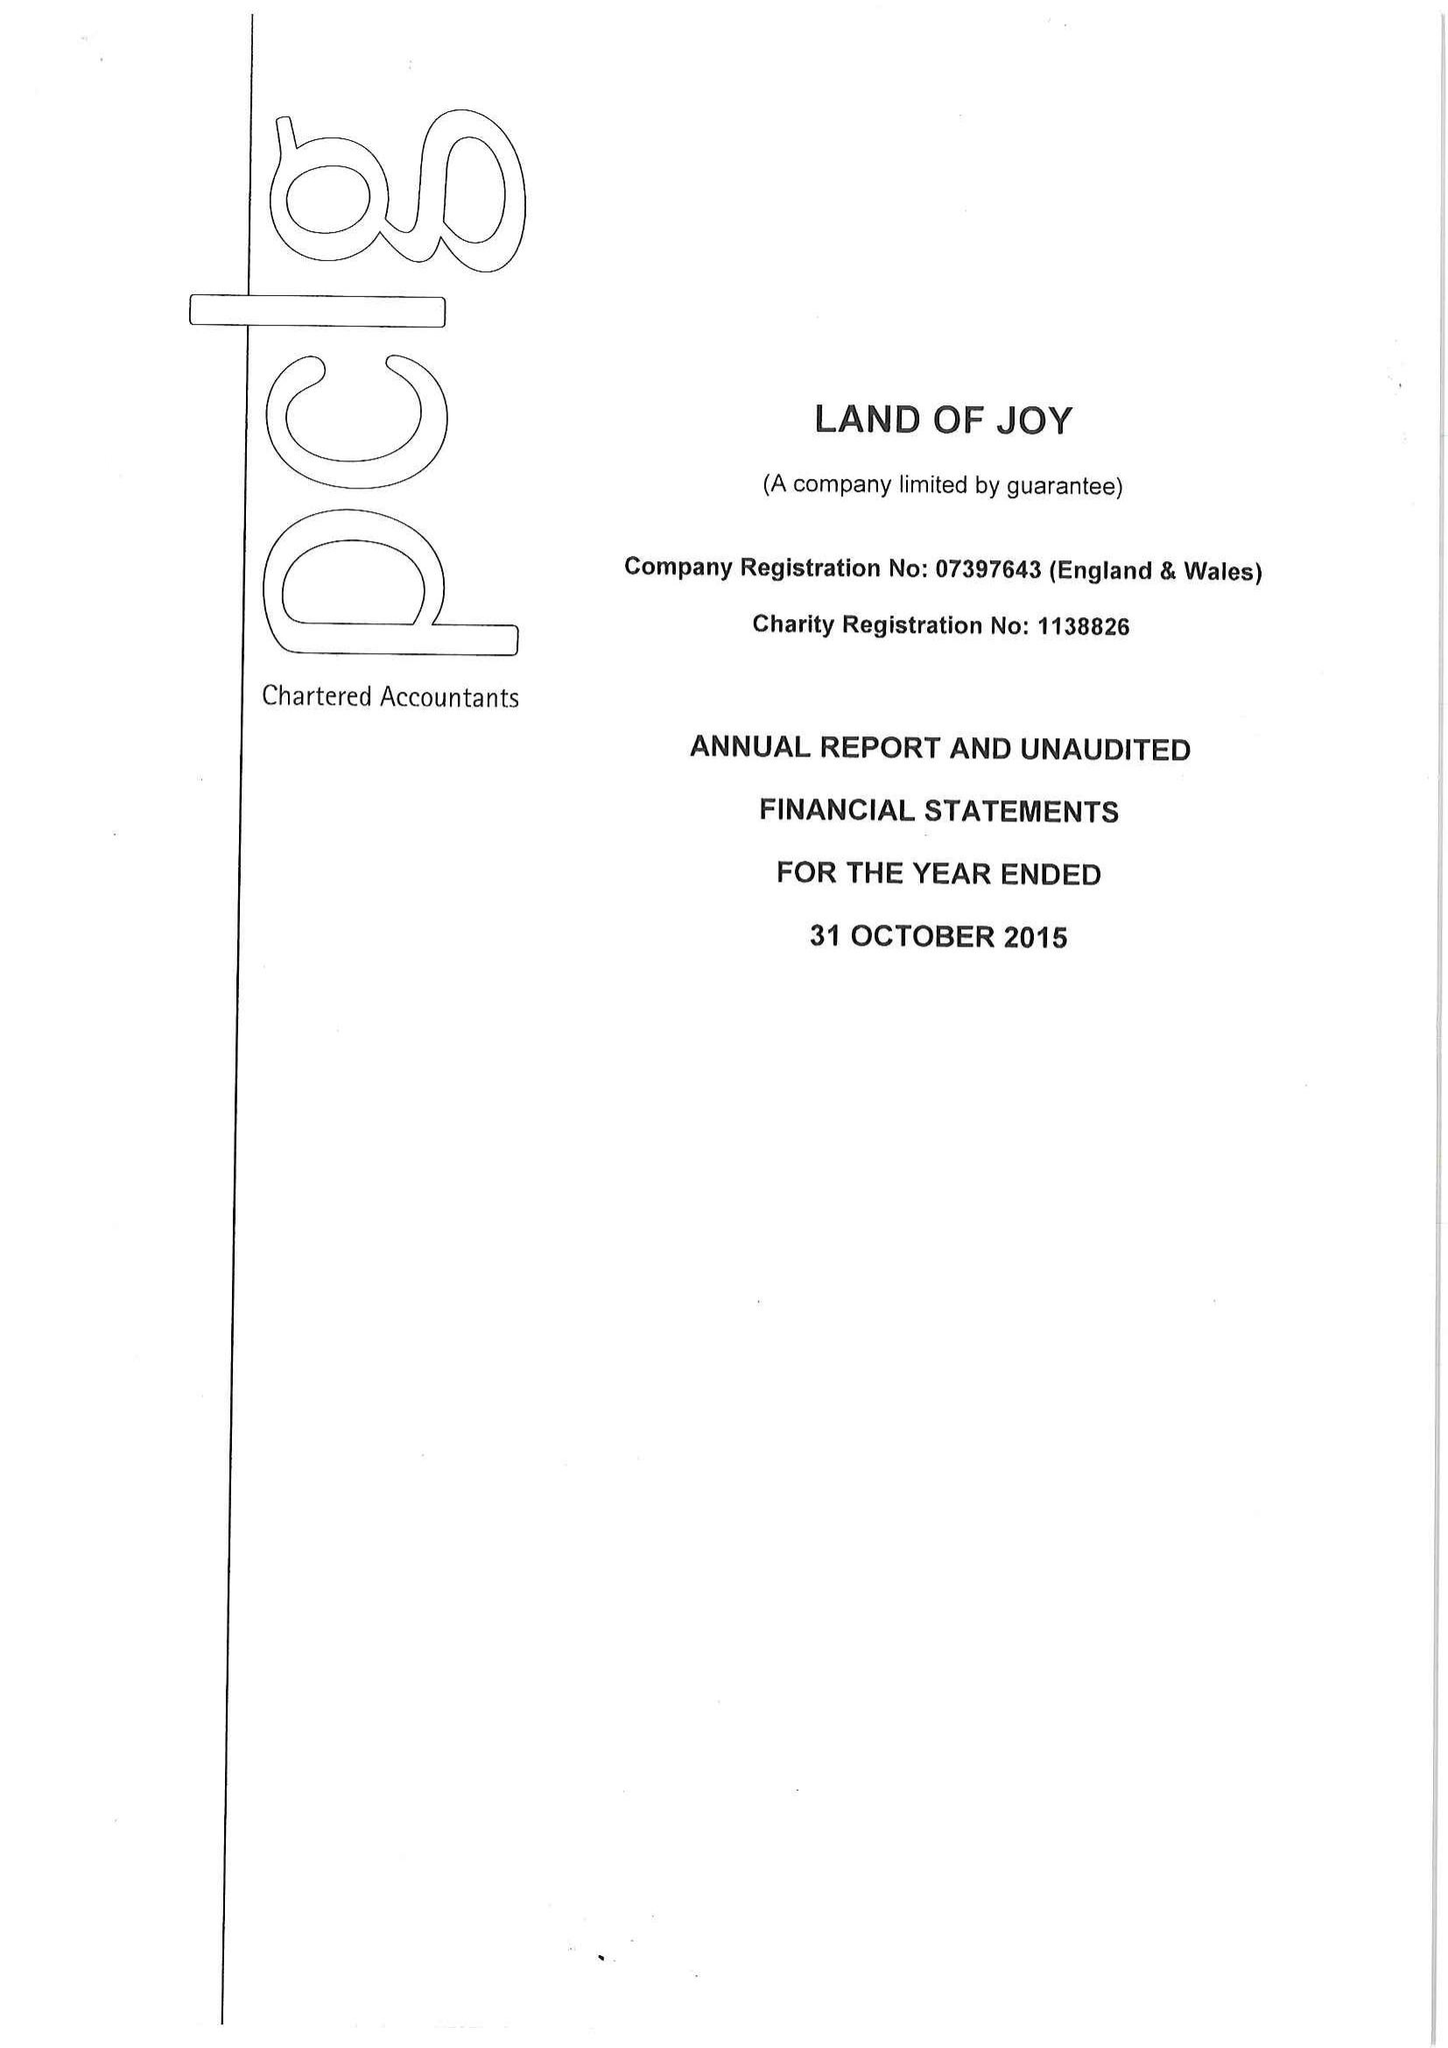What is the value for the report_date?
Answer the question using a single word or phrase. 2015-10-31 